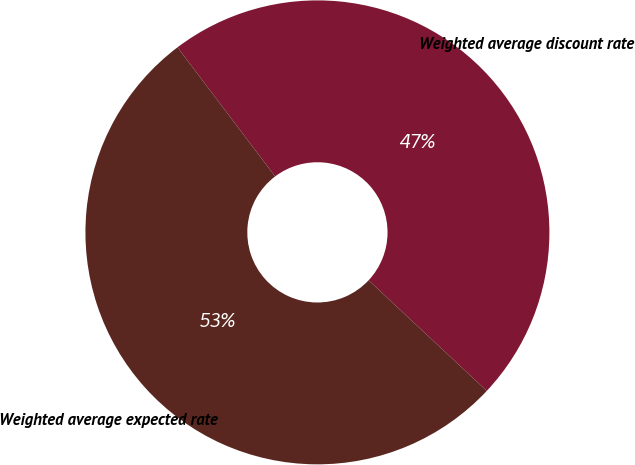Convert chart. <chart><loc_0><loc_0><loc_500><loc_500><pie_chart><fcel>Weighted average discount rate<fcel>Weighted average expected rate<nl><fcel>47.28%<fcel>52.72%<nl></chart> 